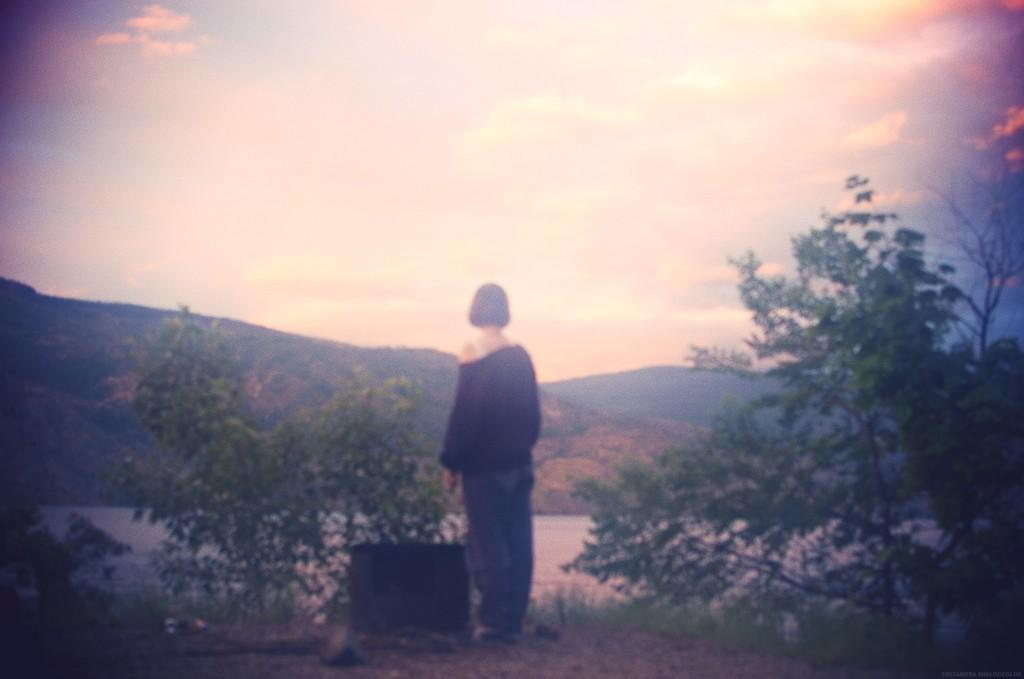What is the person in the image doing? The person is standing on the ground in the image. What type of terrain is visible in the image? There is grass visible in the image. What other natural elements can be seen in the image? There are trees and water visible in the image. What is the background of the image? There is a mountain in the background of the image, and the sky is visible with clouds present. What type of adjustment can be seen on the notebook in the image? There is no notebook present in the image; it features a person standing on the ground with natural elements in the background. 